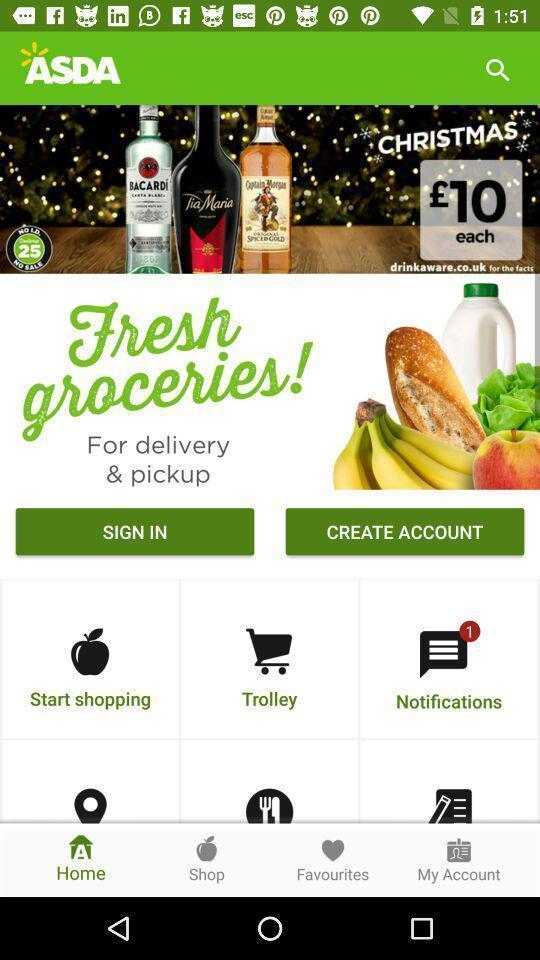Tell me about the visual elements in this screen capture. Sign in page. 